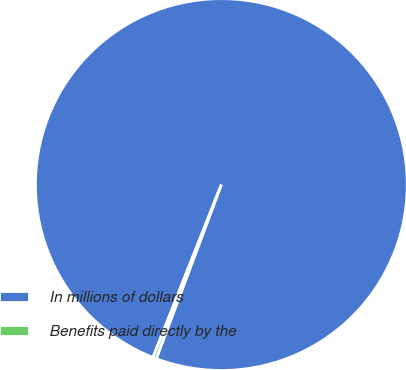Convert chart. <chart><loc_0><loc_0><loc_500><loc_500><pie_chart><fcel>In millions of dollars<fcel>Benefits paid directly by the<nl><fcel>99.7%<fcel>0.3%<nl></chart> 